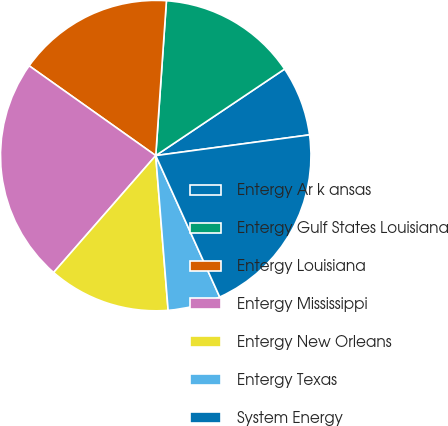<chart> <loc_0><loc_0><loc_500><loc_500><pie_chart><fcel>Entergy Ar k ansas<fcel>Entergy Gulf States Louisiana<fcel>Entergy Louisiana<fcel>Entergy Mississippi<fcel>Entergy New Orleans<fcel>Entergy Texas<fcel>System Energy<nl><fcel>7.28%<fcel>14.49%<fcel>16.28%<fcel>23.39%<fcel>12.7%<fcel>5.49%<fcel>20.37%<nl></chart> 